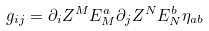<formula> <loc_0><loc_0><loc_500><loc_500>g _ { i j } = \partial _ { i } Z ^ { M } E _ { M } ^ { a } \partial _ { j } Z ^ { N } E _ { N } ^ { b } \eta _ { a b }</formula> 